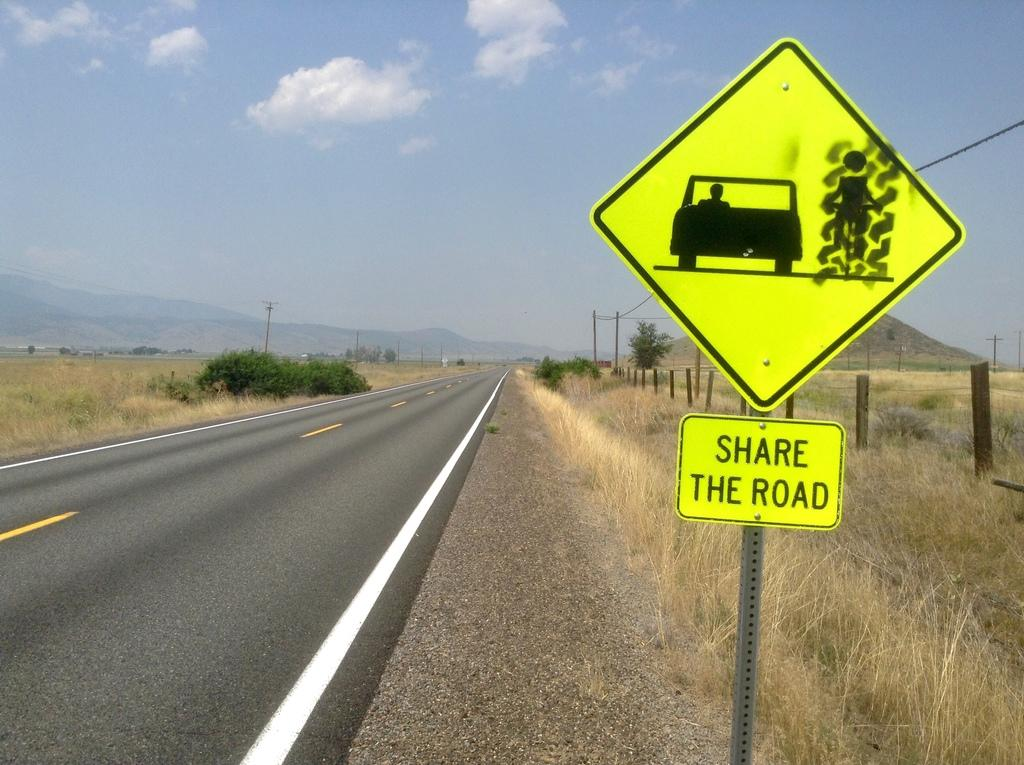<image>
Write a terse but informative summary of the picture. share the road sign of a vehicle and a person to the right of them next to a road in the country side. 